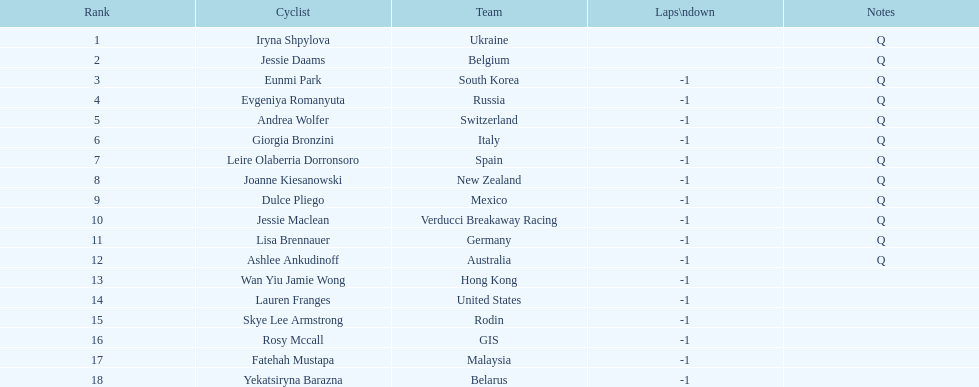Who was the competitor that finished above jessie maclean? Dulce Pliego. 